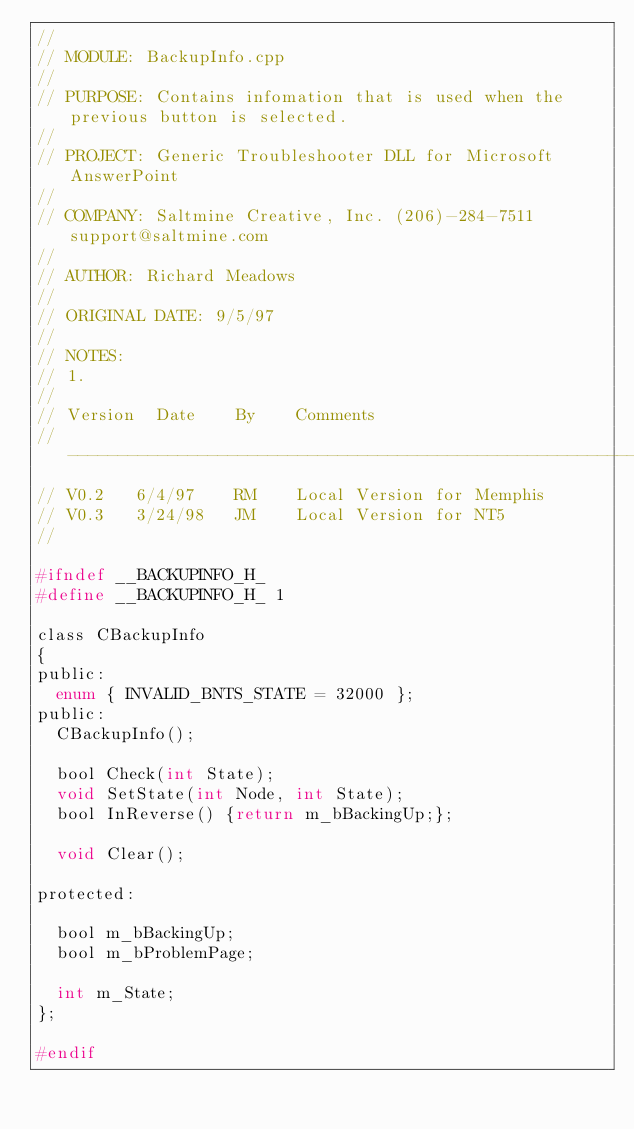Convert code to text. <code><loc_0><loc_0><loc_500><loc_500><_C_>//
// MODULE: BackupInfo.cpp
//
// PURPOSE: Contains infomation that is used when the previous button is selected.
//
// PROJECT: Generic Troubleshooter DLL for Microsoft AnswerPoint
//
// COMPANY: Saltmine Creative, Inc. (206)-284-7511 support@saltmine.com
//
// AUTHOR: Richard Meadows
// 
// ORIGINAL DATE: 9/5/97
//
// NOTES: 
// 1. 
//
// Version	Date		By		Comments
//--------------------------------------------------------------------
// V0.2		6/4/97		RM		Local Version for Memphis
// V0.3		3/24/98		JM		Local Version for NT5
//

#ifndef __BACKUPINFO_H_
#define __BACKUPINFO_H_ 1

class CBackupInfo
{
public:
	enum { INVALID_BNTS_STATE = 32000 };
public:
	CBackupInfo();

	bool Check(int State);
	void SetState(int Node, int State);
	bool InReverse() {return m_bBackingUp;};

	void Clear();

protected:

	bool m_bBackingUp;
	bool m_bProblemPage;

	int m_State;
};

#endif</code> 